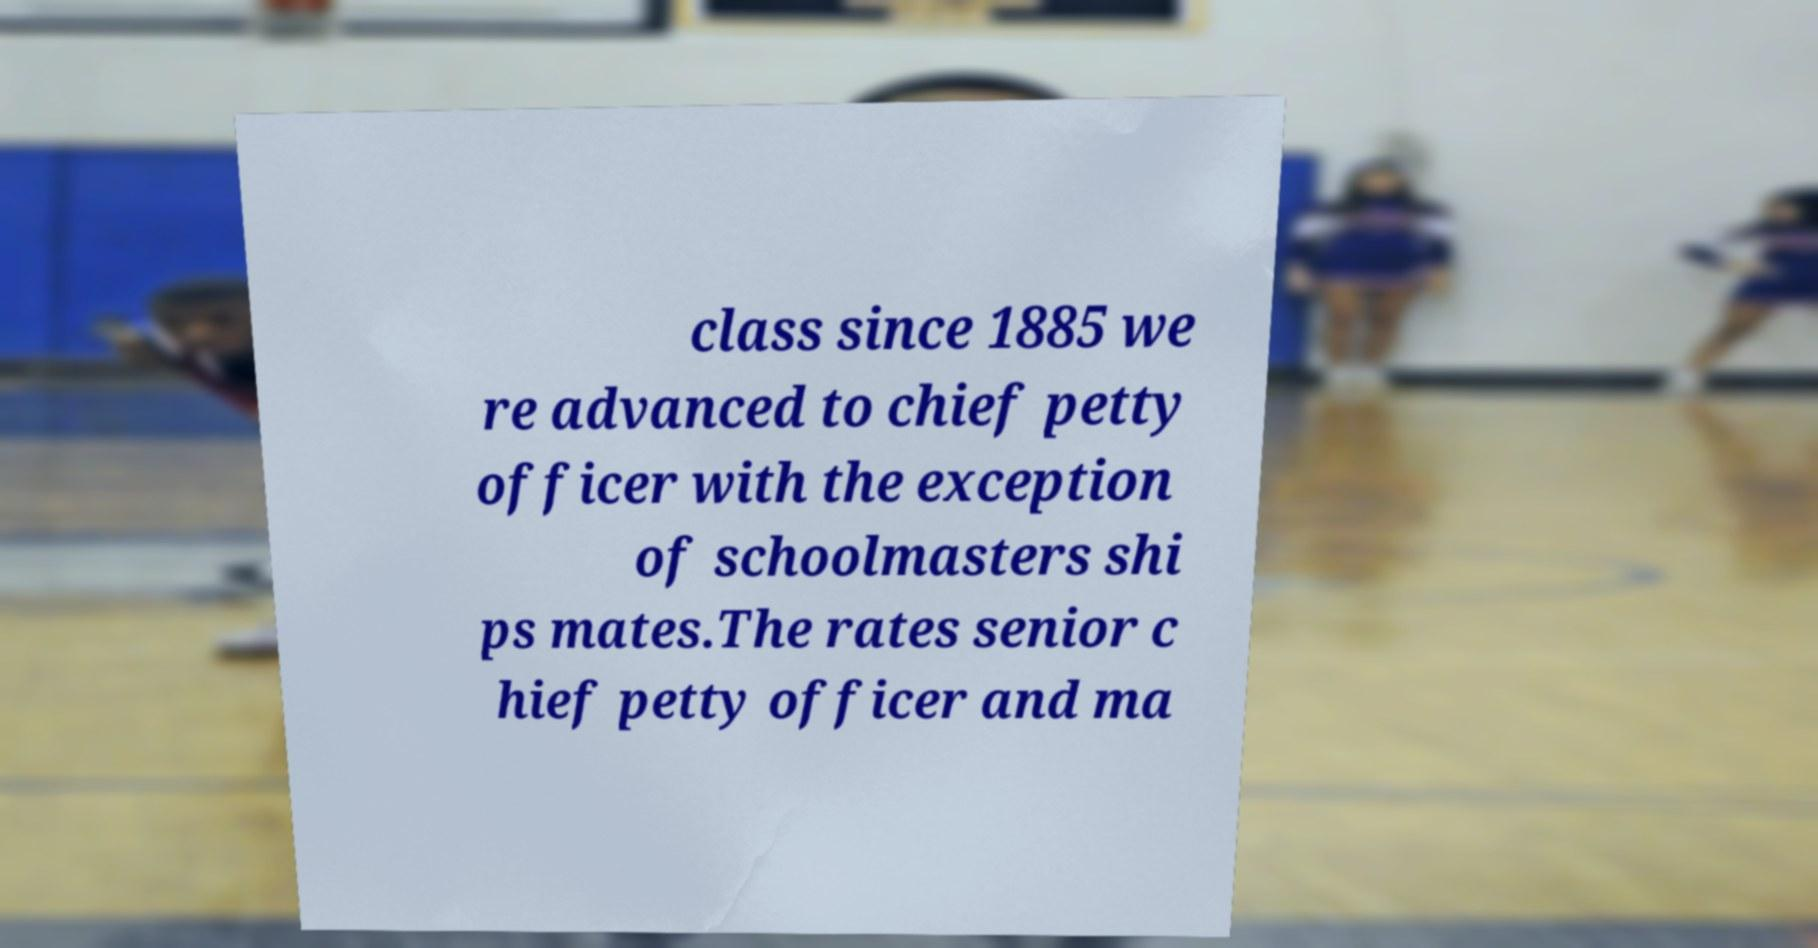Please read and relay the text visible in this image. What does it say? class since 1885 we re advanced to chief petty officer with the exception of schoolmasters shi ps mates.The rates senior c hief petty officer and ma 